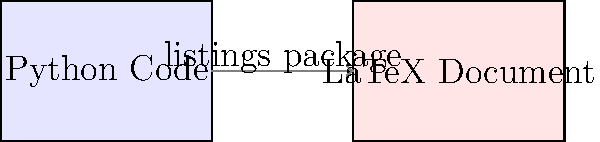In a LaTeX document, you want to include a Python code snippet with syntax highlighting. Which package should you use, and what is the basic structure of the LaTeX code to achieve this? To include a Python code snippet with syntax highlighting in a LaTeX document, follow these steps:

1. Use the listings package:
   - Add \usepackage{listings} in the preamble of your LaTeX document.

2. Set up Python language support:
   - Add \lstset{language=Python} after loading the package.

3. Define the basic structure:
   - Use \begin{lstlisting} and \end{lstlisting} environment to enclose your Python code.

4. Example LaTeX code structure:

   \documentclass{article}
   \usepackage{listings}
   \lstset{language=Python}
   
   \begin{document}
   
   \begin{lstlisting}
   def hello_world():
       print("Hello, World!")
   
   hello_world()
   \end{lstlisting}
   
   \end{document}

This setup will display your Python code with basic syntax highlighting in your LaTeX document.
Answer: Use the listings package with \begin{lstlisting} and \end{lstlisting} environment. 